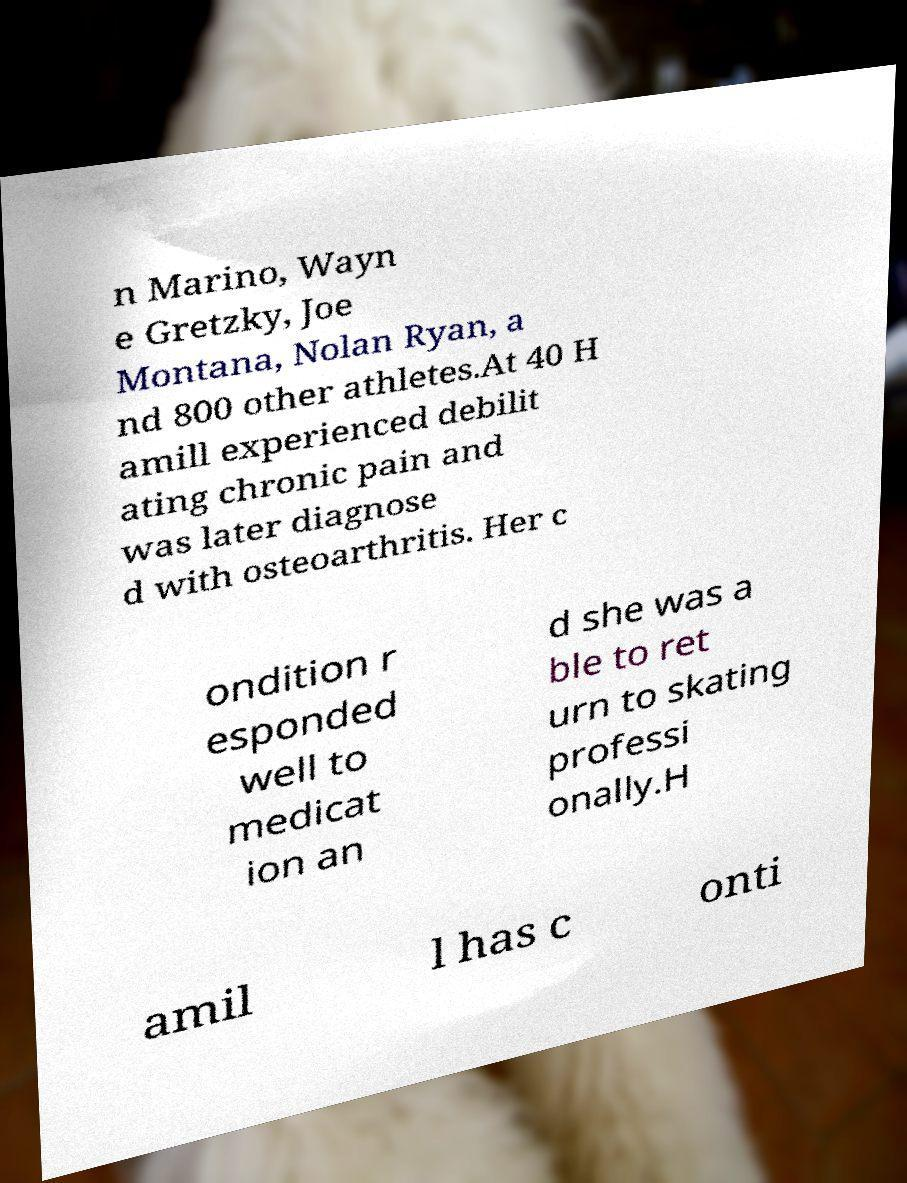Could you extract and type out the text from this image? n Marino, Wayn e Gretzky, Joe Montana, Nolan Ryan, a nd 800 other athletes.At 40 H amill experienced debilit ating chronic pain and was later diagnose d with osteoarthritis. Her c ondition r esponded well to medicat ion an d she was a ble to ret urn to skating professi onally.H amil l has c onti 